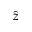Convert formula to latex. <formula><loc_0><loc_0><loc_500><loc_500>\hat { z }</formula> 